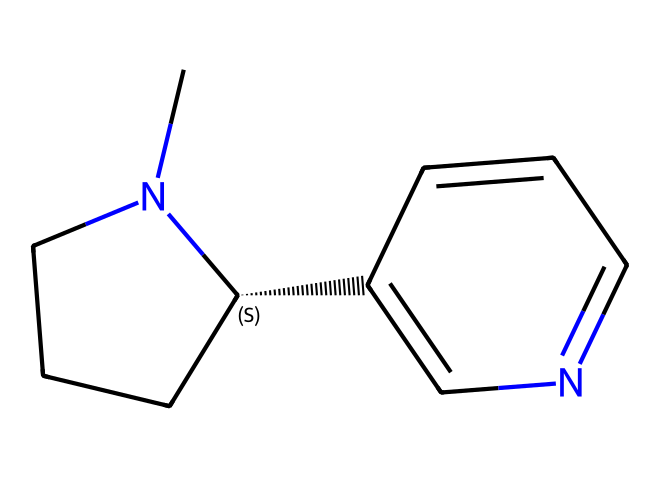what is the molecular formula of this chemical? To determine the molecular formula, we need to count the number of carbon (C), hydrogen (H), and nitrogen (N) atoms in the SMILES notation. The chemical structure reveals 10 carbon atoms, 14 hydrogen atoms, and 2 nitrogen atoms, leading to the formula C10H14N2.
Answer: C10H14N2 how many nitrogen atoms are present in the structure? Observing the SMILES notation shows two instances of nitrogen (N), indicating there are two nitrogen atoms in the structure.
Answer: 2 what type of chemical is nicotine classified as? Nicotine is specifically classified as an alkaloid, a type of chemical compound that is basic and often derived from plant sources, which is evident from its structure containing nitrogen.
Answer: alkaloid how does the presence of nitrogen affect the properties of nicotine? Nitrogen introduces basic properties to nicotine, enhancing its pharmacological effects, such as being a stimulant and affecting neurotransmitter activity in the brain, which is characteristic of alkaloids.
Answer: basic properties what is the significance of nicotine in historical social changes? Nicotine has played a pivotal role in social change, notably in movements related to health awareness and tobacco regulation, influencing public policy and perceptions surrounding its use.
Answer: social change 